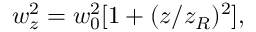Convert formula to latex. <formula><loc_0><loc_0><loc_500><loc_500>w _ { z } ^ { 2 } = w _ { 0 } ^ { 2 } [ 1 + ( z / z _ { R } ) ^ { 2 } ] ,</formula> 